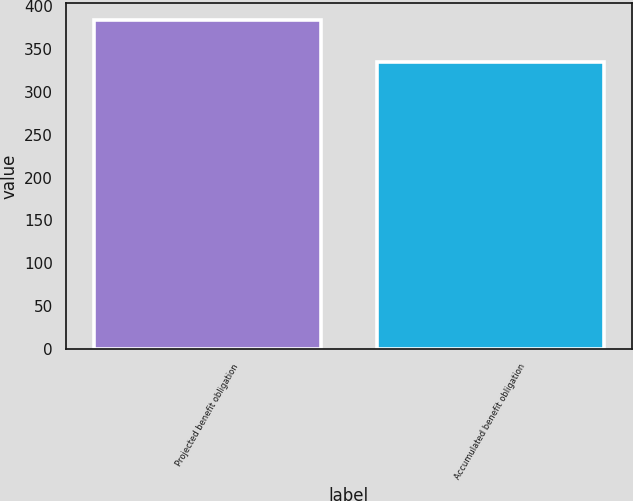Convert chart to OTSL. <chart><loc_0><loc_0><loc_500><loc_500><bar_chart><fcel>Projected benefit obligation<fcel>Accumulated benefit obligation<nl><fcel>384.3<fcel>334.6<nl></chart> 